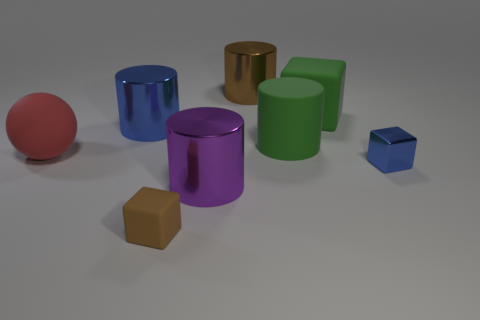What shape is the thing that is to the right of the brown cylinder and in front of the red matte ball? cube 